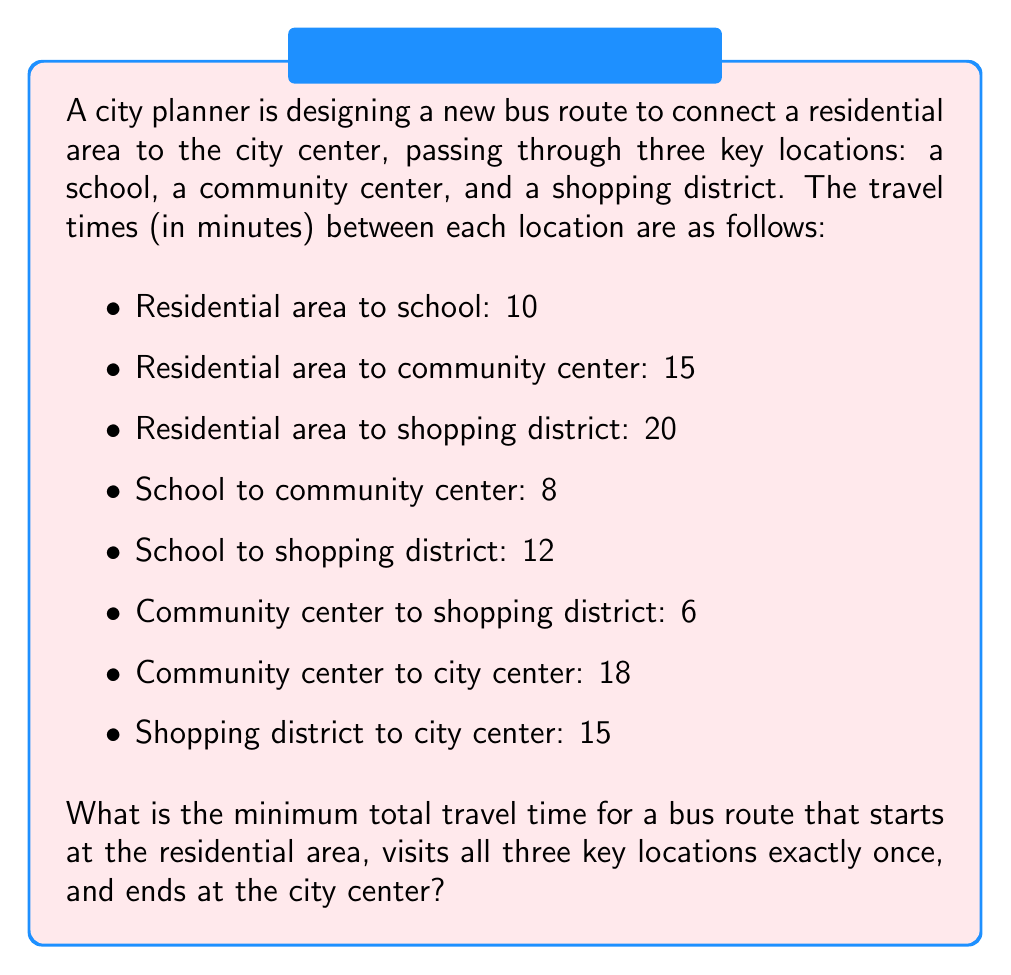Can you solve this math problem? This problem can be solved using a combinatorial optimization approach. We need to find the shortest path that visits all required locations.

Let's consider all possible routes:

1. Residential → School → Community Center → Shopping District → City Center
2. Residential → School → Shopping District → Community Center → City Center
3. Residential → Community Center → School → Shopping District → City Center
4. Residential → Community Center → Shopping District → School → City Center
5. Residential → Shopping District → School → Community Center → City Center
6. Residential → Shopping District → Community Center → School → City Center

Let's calculate the total time for each route:

1. $10 + 8 + 6 + 15 = 39$ minutes
2. $10 + 12 + 6 + 18 = 46$ minutes
3. $15 + 8 + 12 + 15 = 50$ minutes
4. $15 + 6 + 12 + 15 = 48$ minutes
5. $20 + 12 + 8 + 18 = 58$ minutes
6. $20 + 6 + 8 + 15 = 49$ minutes

The minimum travel time is achieved by route 1, which takes 39 minutes.

This problem is a simplified version of the Traveling Salesman Problem, which becomes more complex with a larger number of locations. For a small number of locations like in this problem, evaluating all possible routes is feasible. For larger problems, more advanced algorithms such as dynamic programming or heuristic methods would be necessary.
Answer: 39 minutes 